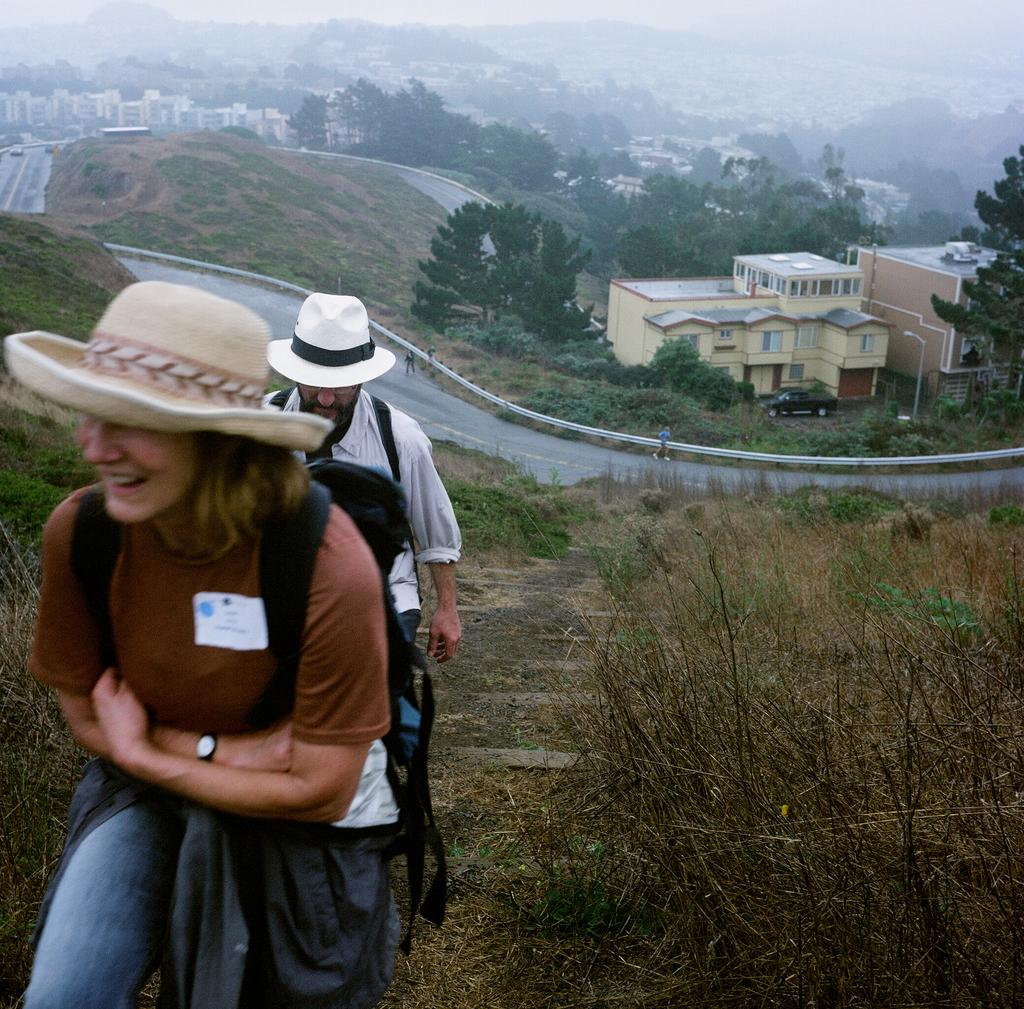Where was the image taken? The image is taken outdoors. How many people are in the image? There are two people in the image. What are the people doing in the image? The people are climbing a mountain. What can be seen in the background of the image? There is a road, trees, houses, and fog visible in the background. What type of comb is the grandmother using in the image? There is no grandmother or comb present in the image. 